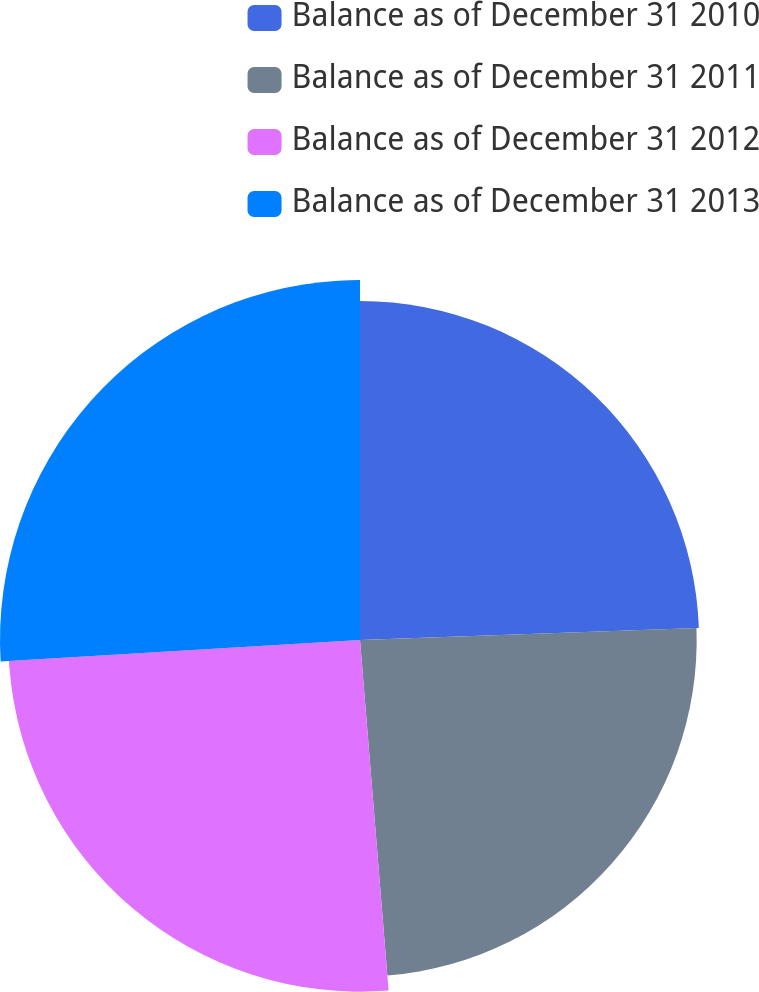<chart> <loc_0><loc_0><loc_500><loc_500><pie_chart><fcel>Balance as of December 31 2010<fcel>Balance as of December 31 2011<fcel>Balance as of December 31 2012<fcel>Balance as of December 31 2013<nl><fcel>24.44%<fcel>24.27%<fcel>25.35%<fcel>25.95%<nl></chart> 